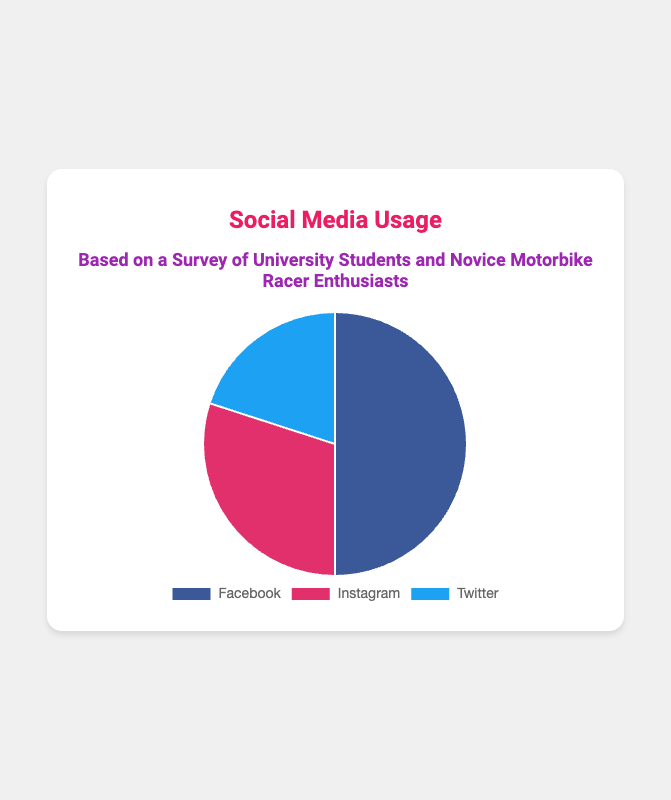Which platform has the highest usage percentage? The pie chart shows three platforms: Facebook, Instagram, and Twitter with usage percentages of 50%, 30%, and 20% respectively. Facebook has the highest usage percentage at 50%.
Answer: Facebook What is the total percentage of usage for Instagram and Twitter combined? To find the total percentage of usage for Instagram and Twitter, we simply add their usage percentages: 30% (Instagram) + 20% (Twitter) = 50%.
Answer: 50% Is the usage of Facebook higher than the combined usage of Instagram and Twitter? The usage percentage of Facebook is 50%. The combined usage of Instagram and Twitter is also 50% (30% + 20%). Since these values are equal, Facebook's usage is not higher.
Answer: No By how much does the usage of Facebook exceed that of Twitter? The usage percentage of Facebook is 50% and that of Twitter is 20%. The difference can be found by subtracting Twitter’s percentage from Facebook’s percentage: 50% - 20% = 30%.
Answer: 30% Which platform has the lowest usage percentage, and what is this percentage? The pie chart shows usage percentages of 50% for Facebook, 30% for Instagram, and 20% for Twitter. The lowest percentage is 20%, and the platform is Twitter.
Answer: Twitter, 20% If we combine the usage of Facebook and Instagram, what is their total share of social media usage? To find the combined usage of Facebook and Instagram, we add their usage percentages: 50% (Facebook) + 30% (Instagram) = 80%.
Answer: 80% Which platforms together have a collective usage that is less than Facebook's usage alone? The platforms are Instagram and Twitter. The combined usage of Instagram and Twitter is 50%, which is equal to Facebook’s usage and not less than Facebook's usage alone. Therefore, no platform combination is less than Facebook's 50%.
Answer: None Is the percentage of Instagram usage closer to that of Facebook's or Twitter's? Instagram has a usage percentage of 30%. The difference between Instagram and Facebook is 20% (50% - 30%) and the difference between Instagram and Twitter is 10% (30% - 20%). Since 10% is smaller than 20%, Instagram's usage is closer to that of Twitter's.
Answer: Twitter Which color represents the platform with the lowest usage? Without specific hex codes, the colors can be described generally observed in the typical palettes. The pie chart uses common colors associated with the platforms: Facebook is typically blue, Instagram is pinkish, and Twitter is light blue. The platform with the lowest usage is Twitter, represented by light blue.
Answer: Light Blue What proportion of the pie chart is taken up by Instagram and Twitter combined? To find the proportion of the pie chart that Instagram and Twitter occupy together, sum their percentages: 30% (Instagram) + 20% (Twitter) = 50%. This means they take up half of the pie chart.
Answer: 50% 